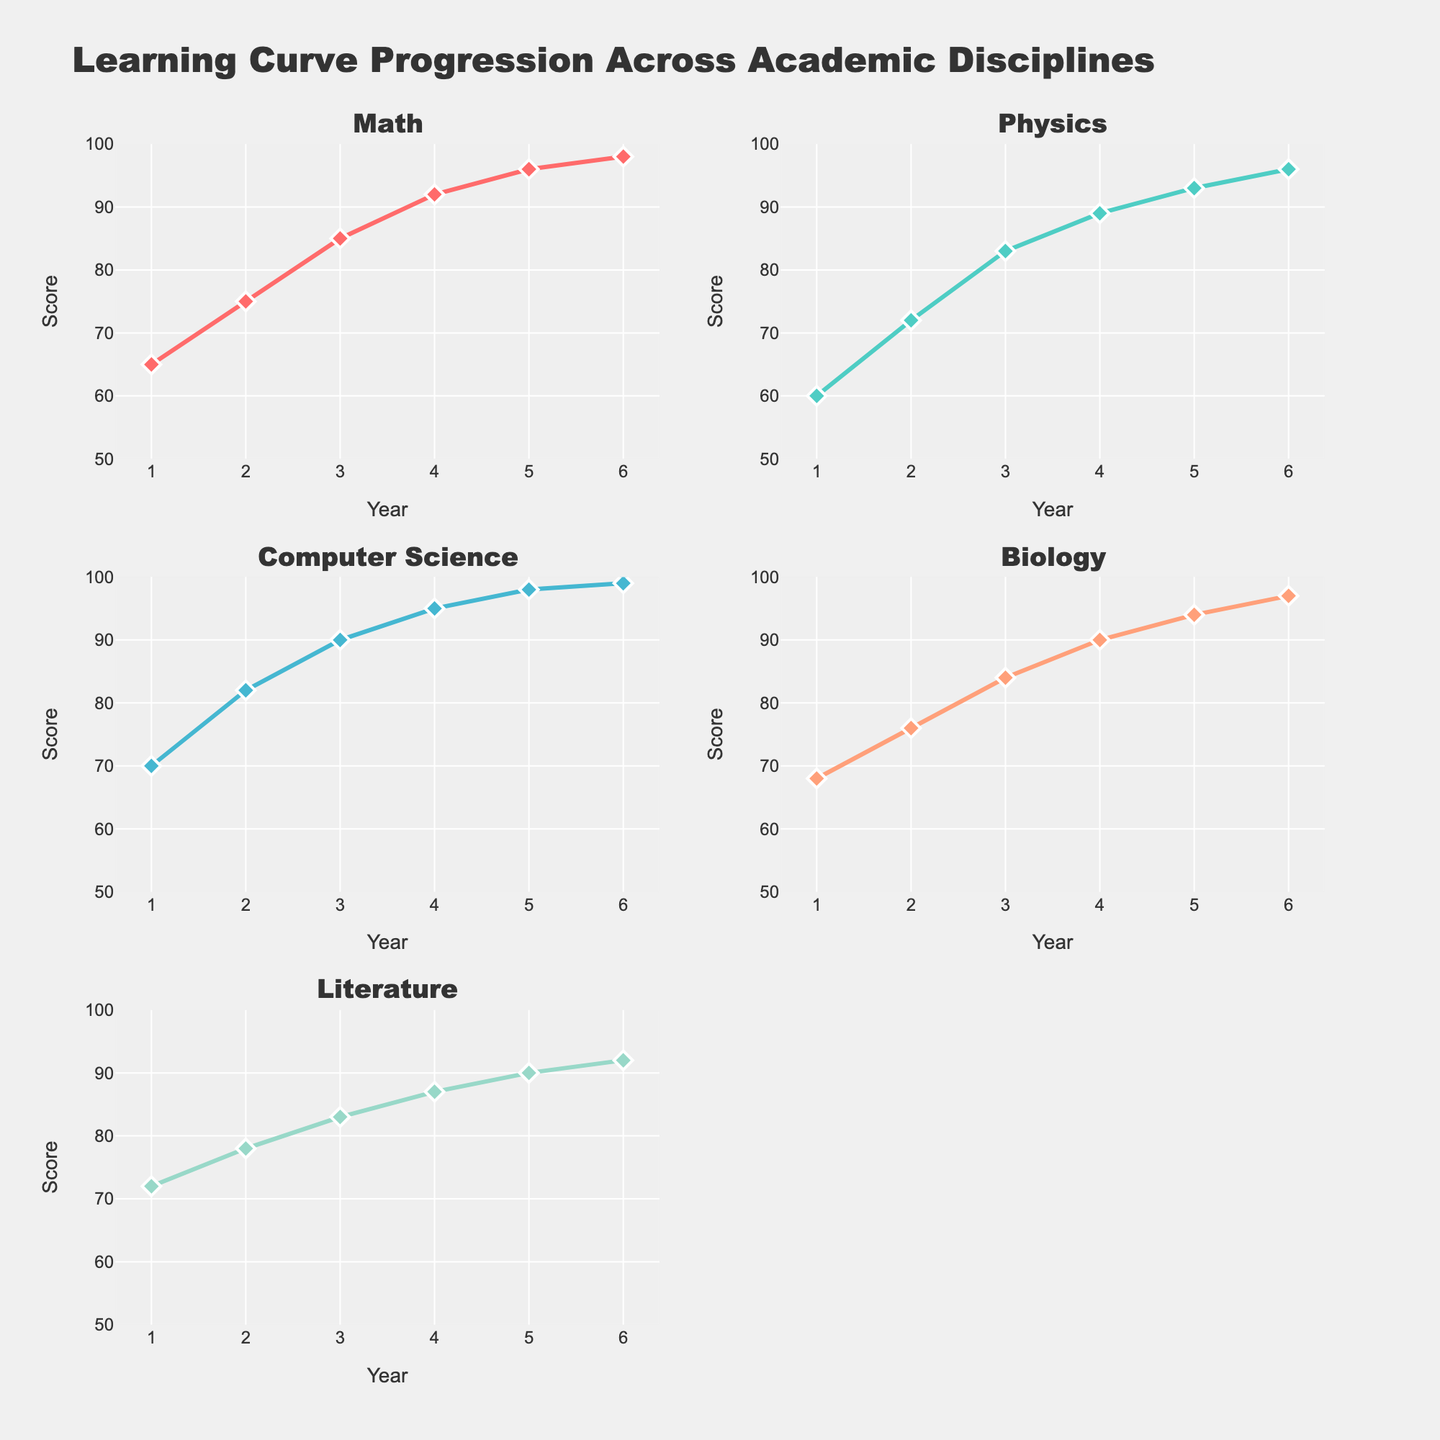What's the title of the figure? The title is typically placed at the top of the figure and represents the overall subject of the visualization. Upon examining the figure, you can see the title clearly displayed.
Answer: Learning Curve Progression Across Academic Disciplines How many academic disciplines are displayed in the subplots? By counting the number of subplot titles or visual representations (lines) within the figure, you can determine the number of academic disciplines. There are five distinct subplots, each titled with an academic discipline.
Answer: 5 Which academic discipline shows the highest score in the Senior year? To answer this, locate the points corresponding to the Senior year (Year 4) in each subplot and observe the respective values. The highest score among Senior year data points appears in the Computer Science subplot.
Answer: Computer Science What's the general trend of scores for the Biology discipline over the years? By observing the line in the Biology subplot, you can see that the scores start around 68 in Freshman year and gradually increase each year, reaching around 97 in Graduate Year 2. This indicates a consistent upward trend.
Answer: Increasing Which discipline shows the most significant improvement between Freshman and Senior years? Calculate the difference between the Freshman year and Senior year scores for each discipline. The differences are: Math (27), Physics (29), Computer Science (25), Biology (22), and Literature (15). Physics shows the highest improvement.
Answer: Physics What is the range of scores shown in the Math subplot? The range is the difference between the maximum and the minimum scores visible in the subplot. From the Math subplot, the minimum score is around 65 (Freshman) and the maximum score is 98 (Graduate Year 2). So, the range is 98 - 65.
Answer: 33 Which academic discipline has the least variance in scores over the years? To determine this, visually assess which subplot has the least spread between its highest and lowest scores. Literature shows the least spread, ranging from around 72 to 92.
Answer: Literature Between Physics and Biology, which has a higher score in the Graduate Year 1? Locate the points for Graduate Year 1 (Year 5) in both the Physics and Biology subplots. Physics has a score of around 93, while Biology has around 94. Thus, Biology has a higher score in that year.
Answer: Biology For which academic discipline do the scores exceed 90, and at what years? Check each subplot to see when the scores cross the 90 mark. Math crosses 90 in Senior year (4), Physics in Senior year (4), Computer Science in Junior year (3), Biology in Senior year (4), and Literature never crosses 90.
Answer: Math (4), Physics (4), Computer Science (3), Biology (4) How do the learning curves for Math and Literature compare over the years? Compare the slopes and data points of the subplots for Math and Literature. Math shows a stronger upward trend with notable increases year over year, while Literature shows a more gradual, less steep increase. Both start below 75 in Freshman year but Math reaches nearly 98, whereas Literature stays below 92.
Answer: Math shows a steeper increase 